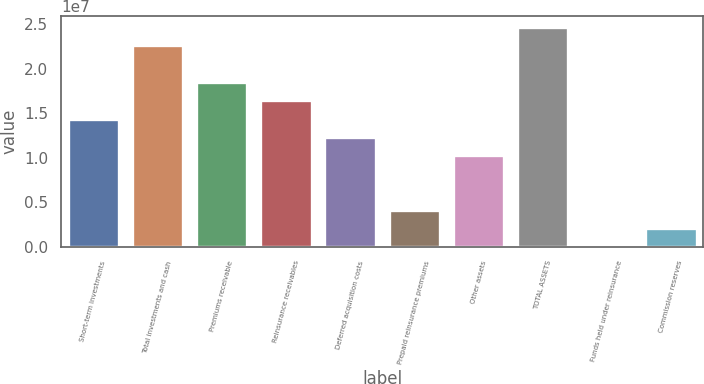Convert chart. <chart><loc_0><loc_0><loc_500><loc_500><bar_chart><fcel>Short-term investments<fcel>Total investments and cash<fcel>Premiums receivable<fcel>Reinsurance receivables<fcel>Deferred acquisition costs<fcel>Prepaid reinsurance premiums<fcel>Other assets<fcel>TOTAL ASSETS<fcel>Funds held under reinsurance<fcel>Commission reserves<nl><fcel>1.43896e+07<fcel>2.26046e+07<fcel>1.84971e+07<fcel>1.64434e+07<fcel>1.23359e+07<fcel>4.121e+06<fcel>1.02822e+07<fcel>2.46583e+07<fcel>13544<fcel>2.06727e+06<nl></chart> 